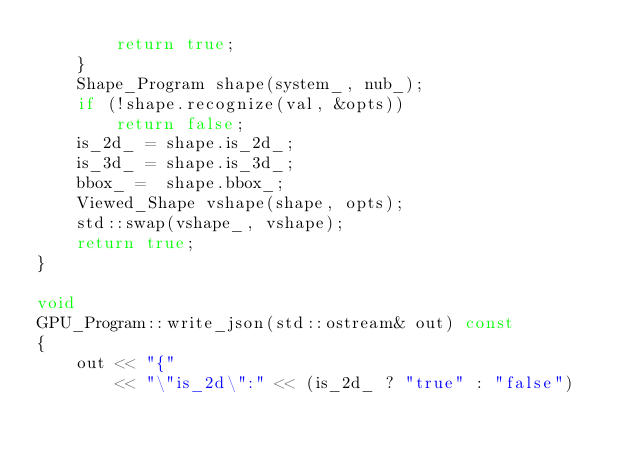<code> <loc_0><loc_0><loc_500><loc_500><_C++_>        return true;
    }
    Shape_Program shape(system_, nub_);
    if (!shape.recognize(val, &opts))
        return false;
    is_2d_ = shape.is_2d_;
    is_3d_ = shape.is_3d_;
    bbox_ =  shape.bbox_;
    Viewed_Shape vshape(shape, opts);
    std::swap(vshape_, vshape);
    return true;
}

void
GPU_Program::write_json(std::ostream& out) const
{
    out << "{"
        << "\"is_2d\":" << (is_2d_ ? "true" : "false")</code> 